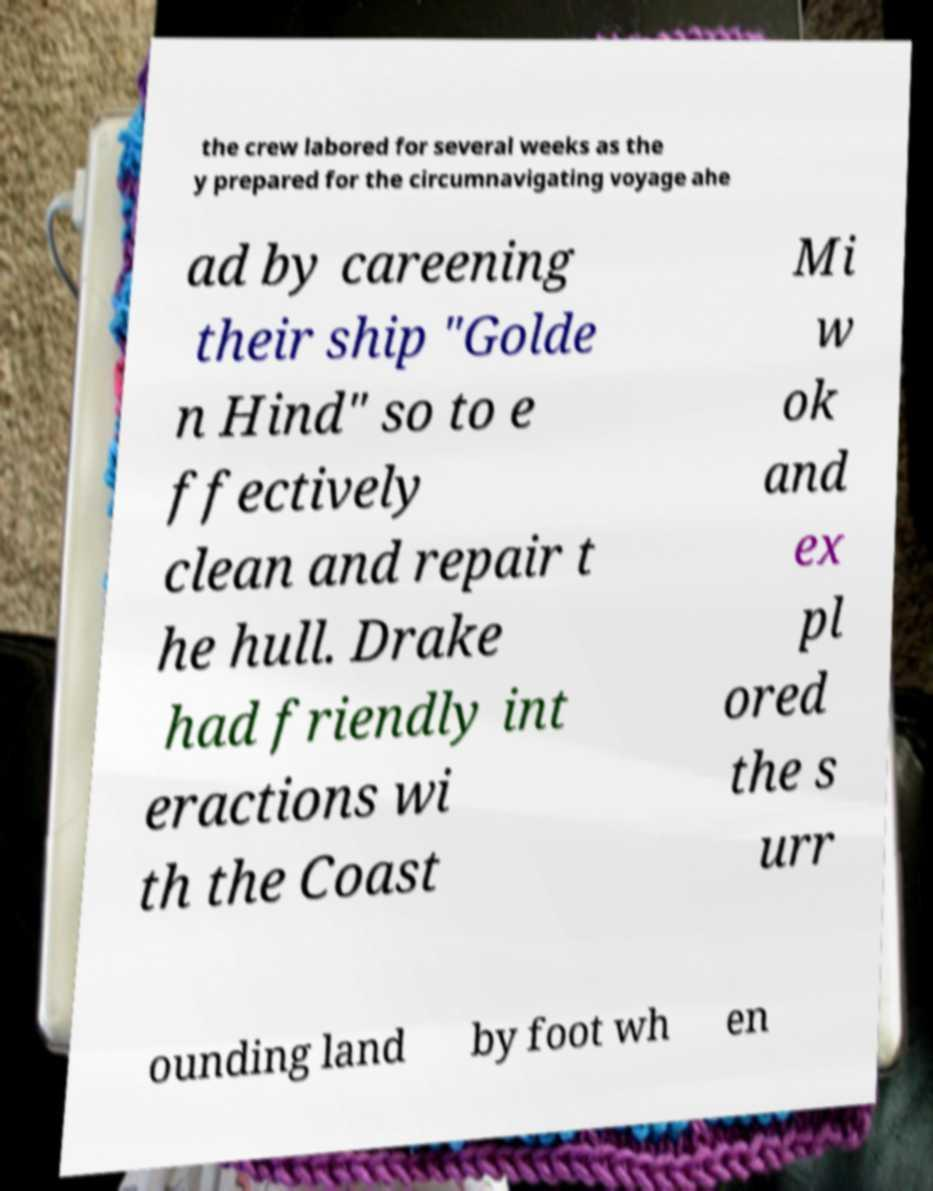Can you read and provide the text displayed in the image?This photo seems to have some interesting text. Can you extract and type it out for me? the crew labored for several weeks as the y prepared for the circumnavigating voyage ahe ad by careening their ship "Golde n Hind" so to e ffectively clean and repair t he hull. Drake had friendly int eractions wi th the Coast Mi w ok and ex pl ored the s urr ounding land by foot wh en 